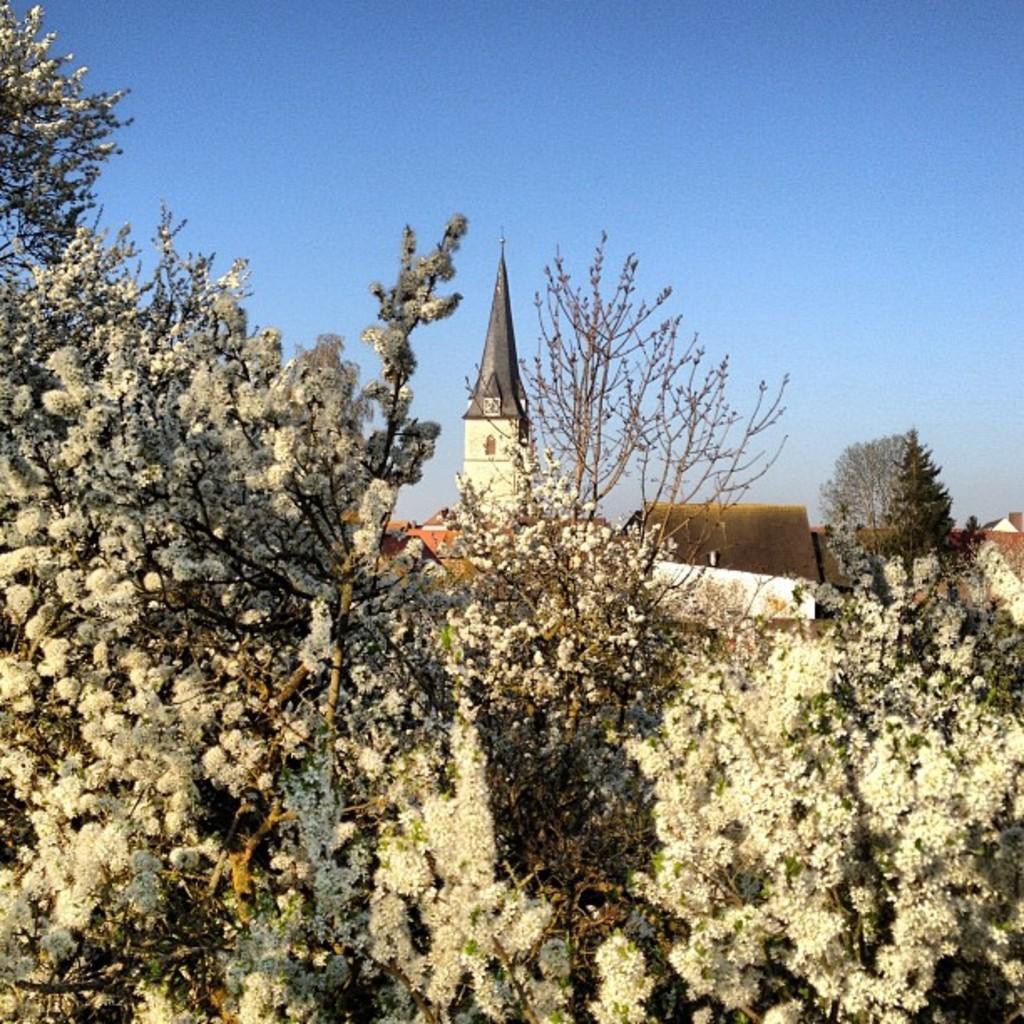Please provide a concise description of this image. In the center of the image we can see trees. In the background, we can see the sky, buildings, one tower, trees and a few other objects. 